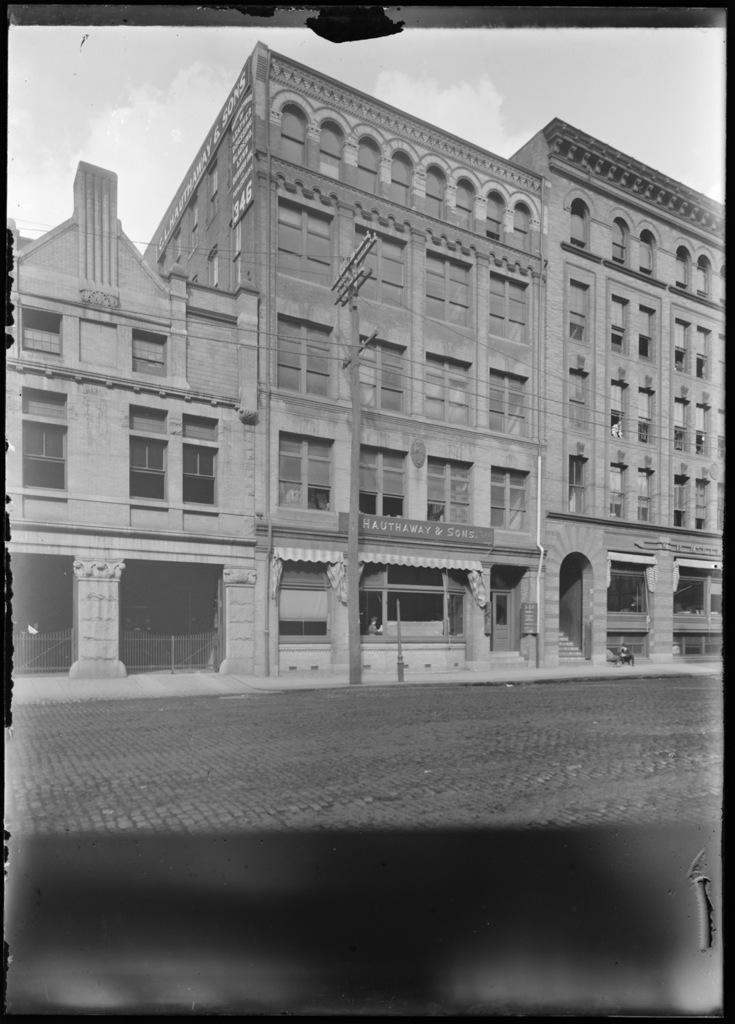What type of structure is in the image? There is a building in the image. What features can be seen on the building? The building has windows, railings, wires, stairs, and pillars. What can be seen in the background of the image? The sky with clouds is visible in the background of the image. What theory is being discussed by the building in the image? There is no indication in the image that the building is discussing any theories. What type of teeth can be seen on the building in the image? Buildings do not have teeth, so there are no teeth visible on the building in the image. 